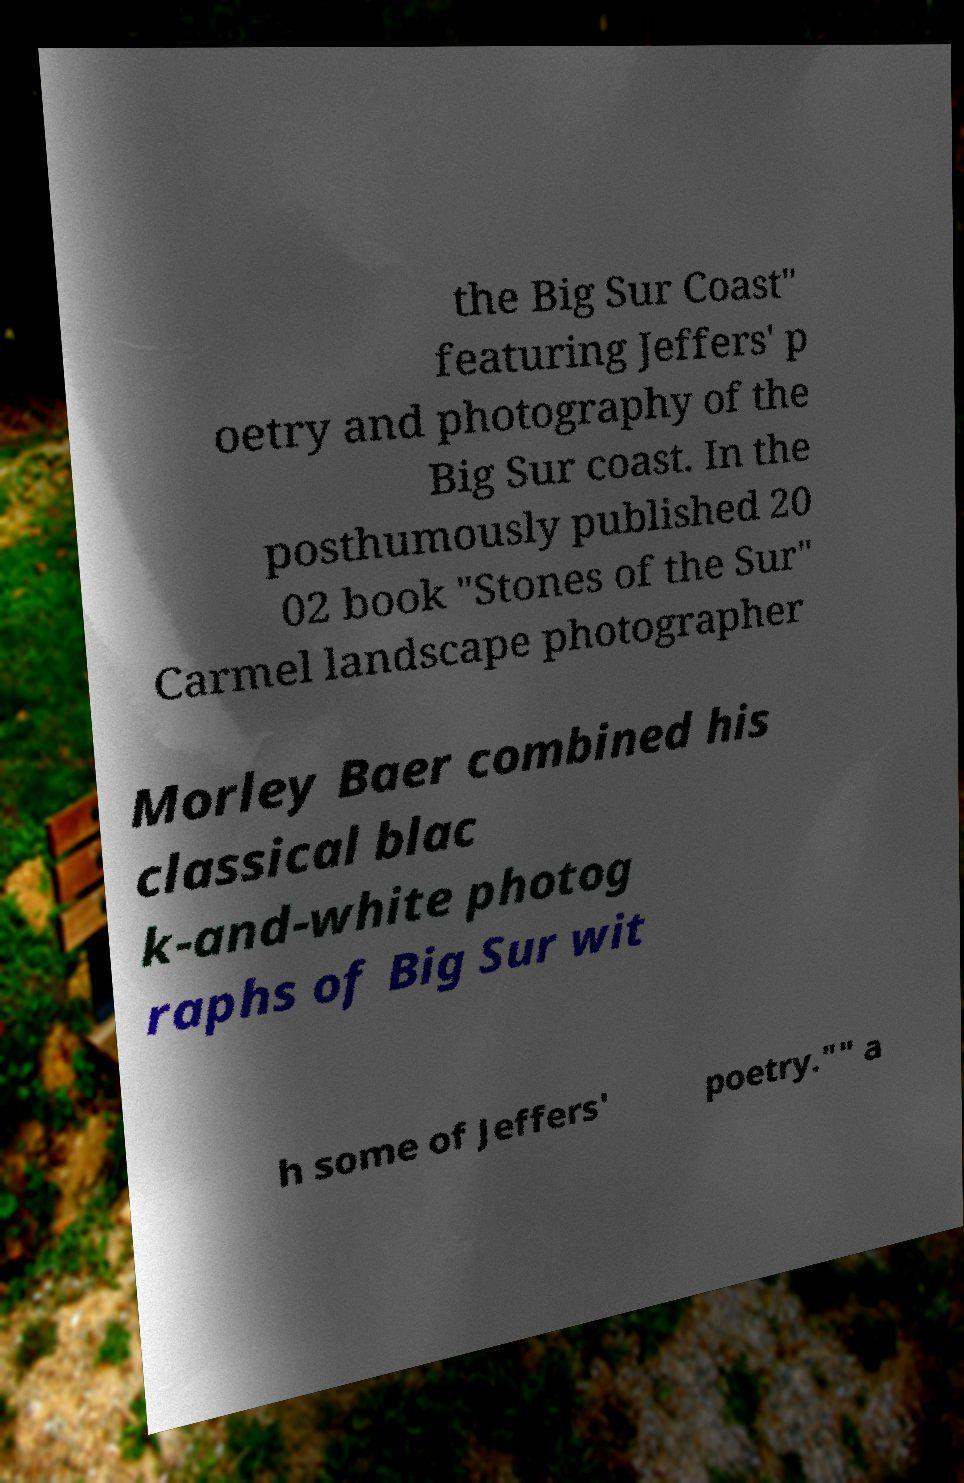Please read and relay the text visible in this image. What does it say? the Big Sur Coast" featuring Jeffers' p oetry and photography of the Big Sur coast. In the posthumously published 20 02 book "Stones of the Sur" Carmel landscape photographer Morley Baer combined his classical blac k-and-white photog raphs of Big Sur wit h some of Jeffers' poetry."" a 